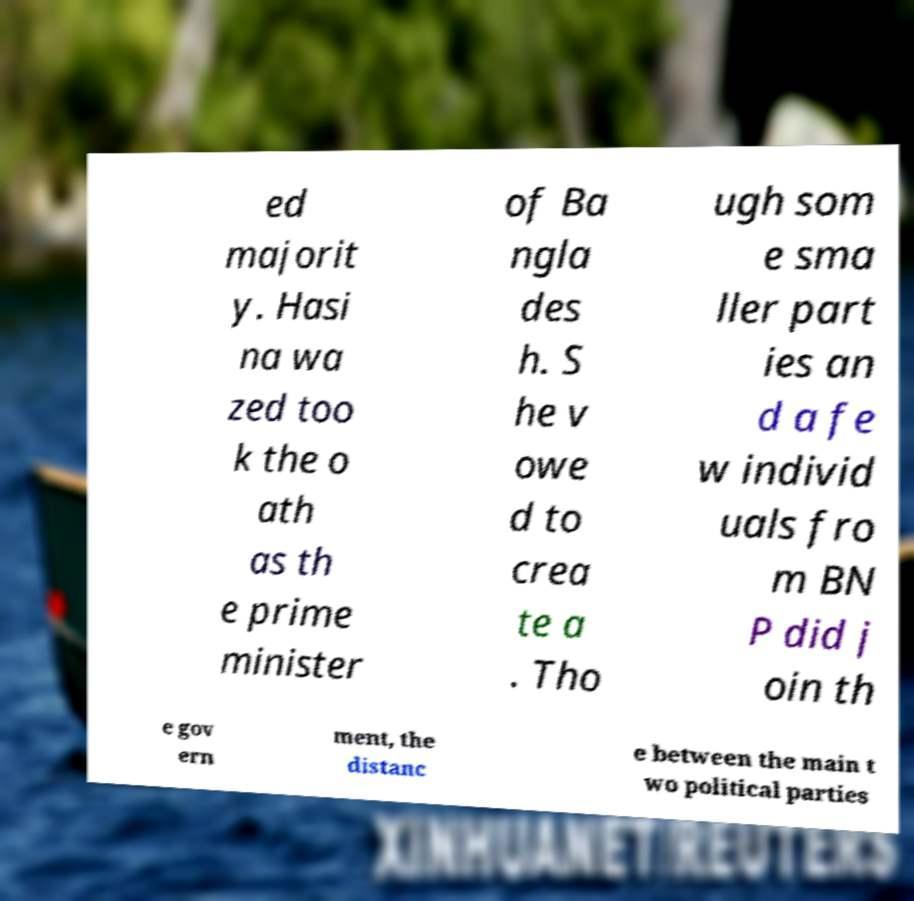Please read and relay the text visible in this image. What does it say? ed majorit y. Hasi na wa zed too k the o ath as th e prime minister of Ba ngla des h. S he v owe d to crea te a . Tho ugh som e sma ller part ies an d a fe w individ uals fro m BN P did j oin th e gov ern ment, the distanc e between the main t wo political parties 